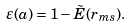Convert formula to latex. <formula><loc_0><loc_0><loc_500><loc_500>\varepsilon ( a ) = 1 - \tilde { E } ( r _ { m s } ) .</formula> 